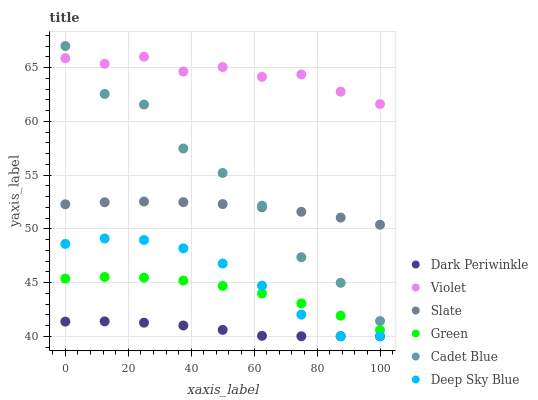Does Dark Periwinkle have the minimum area under the curve?
Answer yes or no. Yes. Does Violet have the maximum area under the curve?
Answer yes or no. Yes. Does Slate have the minimum area under the curve?
Answer yes or no. No. Does Slate have the maximum area under the curve?
Answer yes or no. No. Is Slate the smoothest?
Answer yes or no. Yes. Is Cadet Blue the roughest?
Answer yes or no. Yes. Is Green the smoothest?
Answer yes or no. No. Is Green the roughest?
Answer yes or no. No. Does Deep Sky Blue have the lowest value?
Answer yes or no. Yes. Does Slate have the lowest value?
Answer yes or no. No. Does Cadet Blue have the highest value?
Answer yes or no. Yes. Does Slate have the highest value?
Answer yes or no. No. Is Deep Sky Blue less than Cadet Blue?
Answer yes or no. Yes. Is Violet greater than Dark Periwinkle?
Answer yes or no. Yes. Does Cadet Blue intersect Slate?
Answer yes or no. Yes. Is Cadet Blue less than Slate?
Answer yes or no. No. Is Cadet Blue greater than Slate?
Answer yes or no. No. Does Deep Sky Blue intersect Cadet Blue?
Answer yes or no. No. 